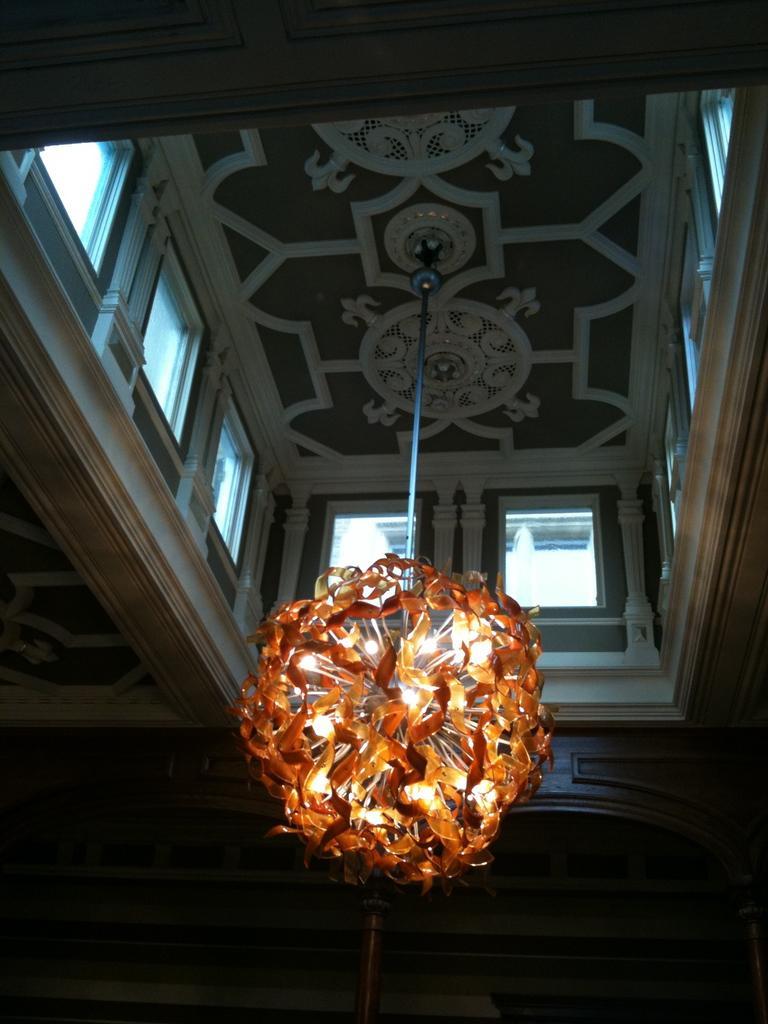What type of location is depicted in the image? The image is an inside picture of a building. What lighting fixture can be seen in the image? There is a chandelier in the image. What type of windows are present in the building? There are glass windows in the image. What type of chalk is being used on the stage in the image? There is no chalk or stage present in the image; it is an inside picture of a building with a chandelier and glass windows. 